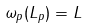Convert formula to latex. <formula><loc_0><loc_0><loc_500><loc_500>\omega _ { p } ( L _ { p } ) = L</formula> 